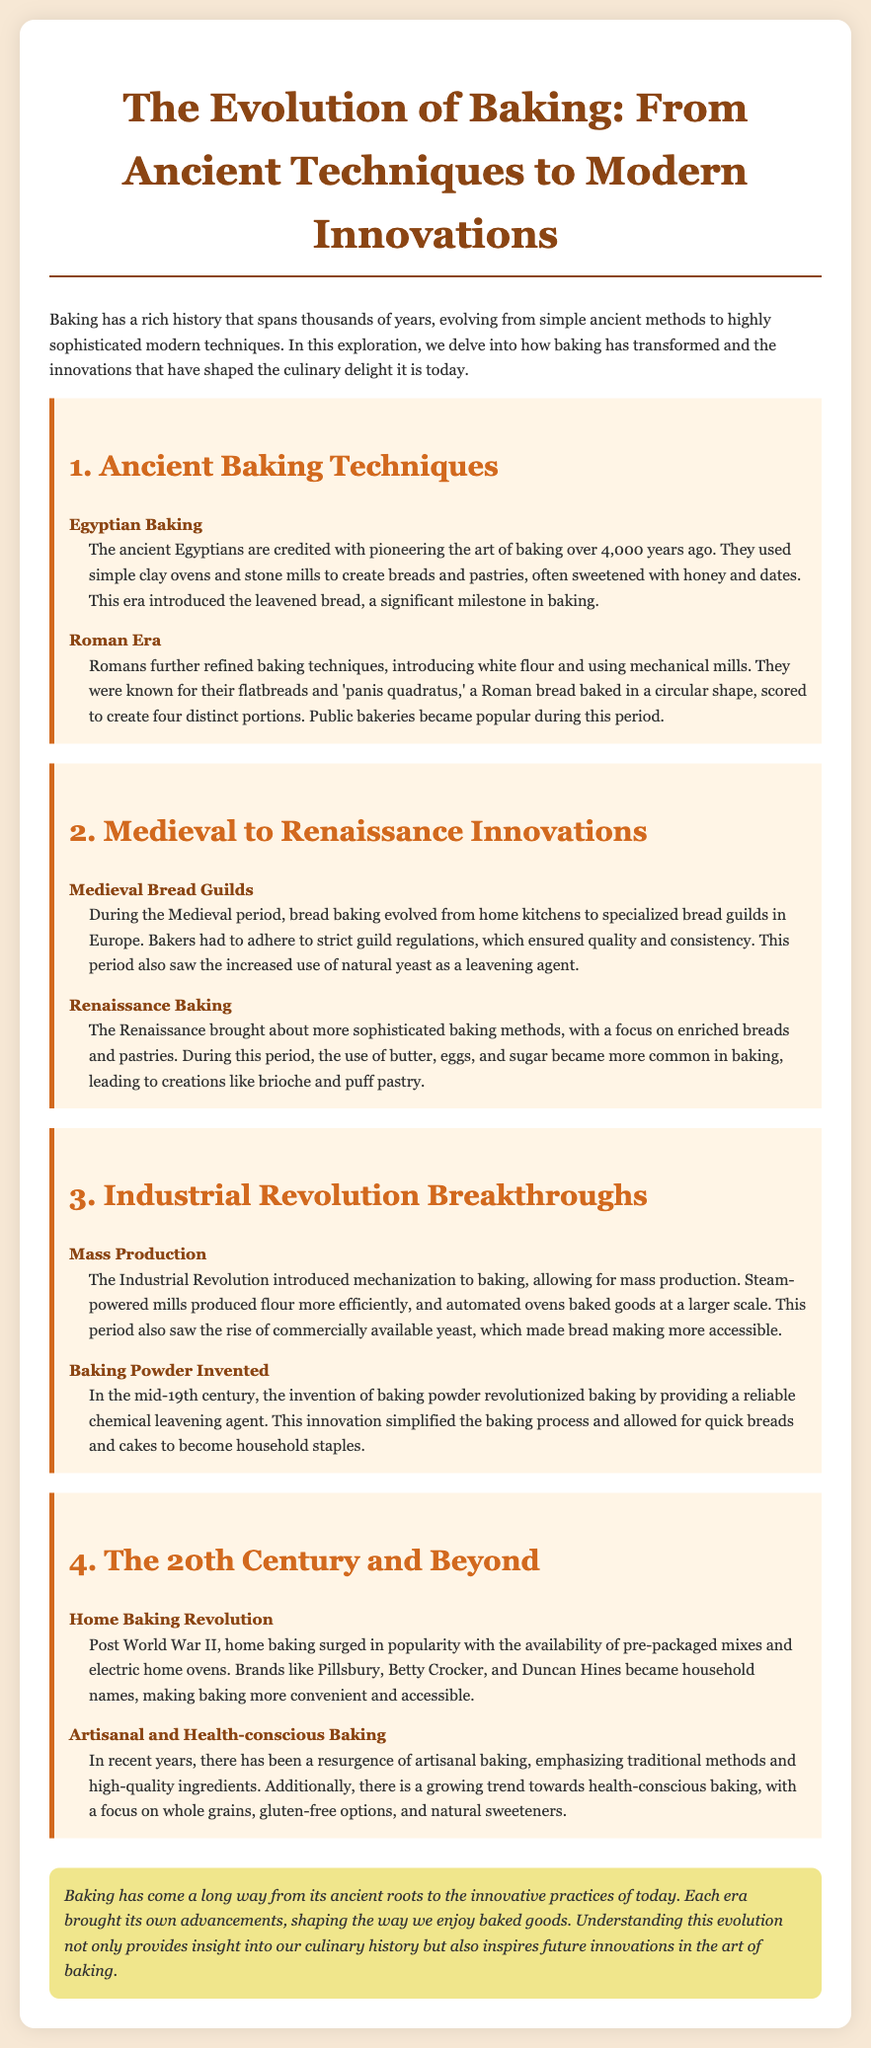What civilization is credited with the origins of baking? The ancient Egyptians are credited with pioneering the art of baking over 4,000 years ago.
Answer: Egyptians What baking innovation was introduced during the Industrial Revolution? The Industrial Revolution introduced mechanization to baking, allowing for mass production.
Answer: Mass production What did Romans use to create white flour? Romans further refined baking techniques, introducing white flour and using mechanical mills.
Answer: Mechanical mills What is a significant milestone in ancient baking? This era introduced the leavened bread, a significant milestone in baking.
Answer: Leavened bread During which era did bakers have to adhere to strict guild regulations? During the Medieval period, bread baking evolved from home kitchens to specialized bread guilds in Europe.
Answer: Medieval period 